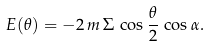<formula> <loc_0><loc_0><loc_500><loc_500>E ( \theta ) = - 2 \, m \, \Sigma \, \cos { \frac { \theta } { 2 } } \, \cos \alpha .</formula> 